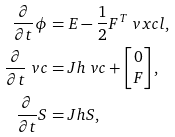<formula> <loc_0><loc_0><loc_500><loc_500>\frac { \partial } { \partial t } \phi & = E - \frac { 1 } { 2 } F ^ { T } \ v x c l , \\ \frac { \partial } { \partial t } \ v c & = J h \ v c + \begin{bmatrix} 0 \\ F \end{bmatrix} , \\ \frac { \partial } { \partial t } S & = J h S ,</formula> 